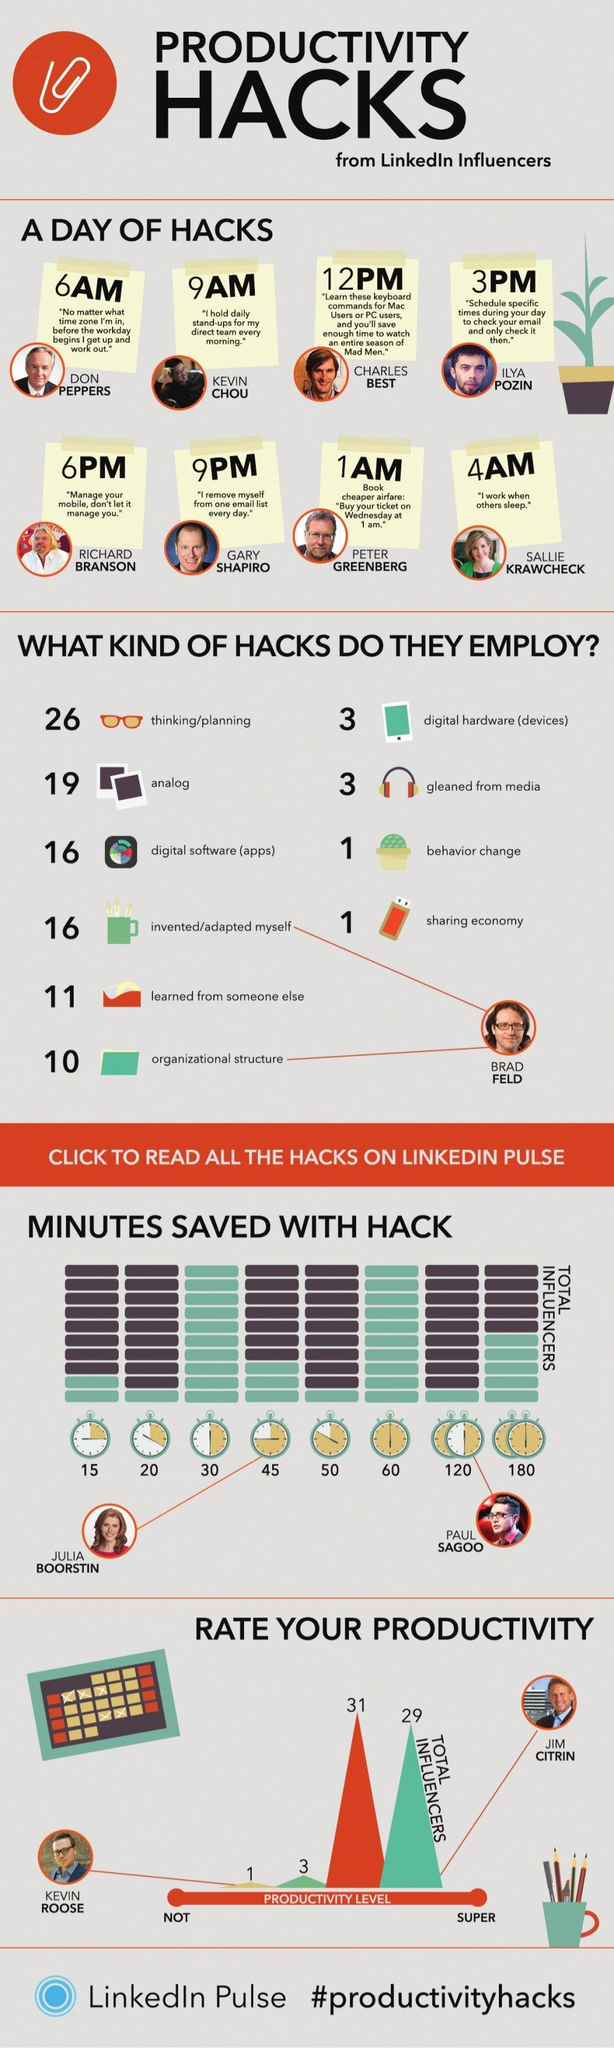Point out several critical features in this image. Peter Greenberg recommends buying a ticket on Wednesday at 1 am. Kevin Chou's hack will take place at 9:00 AM. Brad Feld has invented and adapted several organizational hacks, including the use of a holacracy and a remote-first structure, which have helped improve the efficiency and effectiveness of his companies. Virgin Group founder Richard Branson believes that mobile devices should not control us, but rather, we should control them. Julia Boorstin saved 45 minutes using Hack. 